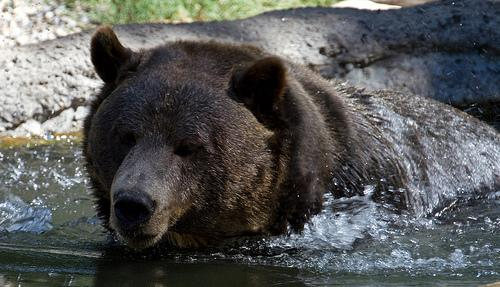Analyze the lighting condition and the presence of any reflections in the image. The image was taken during the daytime, and there is sunlight reflecting off the rocks and logs near the water. Describe any objects found in the water body besides the bear. A log is present in the river, possibly submerged or partially visible, with its black color adding contrast to the scene. State the features present on the bear's face in the image. The bear's face consists of black eyes, a black nose, a long snout, and two small ears. What is the state of the bear's fur in the picture? The bear has wet fur, possibly from swimming or being splashed by the water it is in. Mention the vegetation around the water body in the image. Green grass is growing on the bank of the river next to the pond, providing a natural scene. Comment on the appearance of the rocks in the image. The rocks in the image are grey and appear to be in shadow, with sunlight hitting some of them. Assess the general emotional atmosphere and sentiment conveyed by the image and its elements. The image captures a sense of natural beauty and awe, featuring a powerful bear swimming in a serene water body amidst rocks and green grass. What is the primary animal in the image and what activity is it currently involved in? A large brown bear is swimming in the water, with its fur appearing wet and splashing occurring around it. Describe the appearance of the water in the image. The water in the image is brown and green colored, with white water caps and splashing occurring around the swimming bear. Describe the interaction between the bear and the water. The bear is swimming and splashing water List the objects found in the image with their corresponding image. bear: X:83 Y:54 Width:403 Height:403; logs: X:236 Y:20 Width:244 Height:244; grass: X:107 Y:6 Width:141 Height:141; water: X:15 Y:255 Width:231 Height:231 What is the color of the bear in the image? brown Is the bear sleeping or swimming in the water? swimming Is there a small campfire burning at the edge of the grass by the water? Describe the size, colors, and shape of the flames, as well as any surrounding elements. No, it's not mentioned in the image. Are there any signs of damage or poor quality visible in the image? No signs of damage or poor quality State the emotion conveyed by the bear's appearance. strong and fierce Which task requires analyzing the emotions conveyed by objects in the image? Image Sentiment Analysis Determine the quality of the image in terms of clarity and detail. High clarity and detail What are the colors of the bear's eyes? black What does the OCR text in the image say? No OCR text present in the image How many bears are present in the picture? one bear Locate the referential expressions of sunlight, water, and grass in the image. sunlight: X:1 Y:1 Width:93 Height:93; water: X:15 Y:255 Width:231 Height:231; grass: X:107 Y:6 Width:141 Height:141 What is the time of day depicted in the image? day time State the color of the water in the image. green Describe the position of logs in relation to the bear. Logs are behind the bear Write a short caption for the image. A large brown bear swimming and splashing in the water Identify the object attribute of water caps in the image. white Delineate the boundaries between different regions of the image (bear, water, grass, logs). bear: X:83 Y:54 Width:403 Height:403; water: X:15 Y:255 Width:231 Height:231; grass: X:107 Y:6 Width:141 Height:141; logs: X:236 Y:20 Width:244 Height:244 